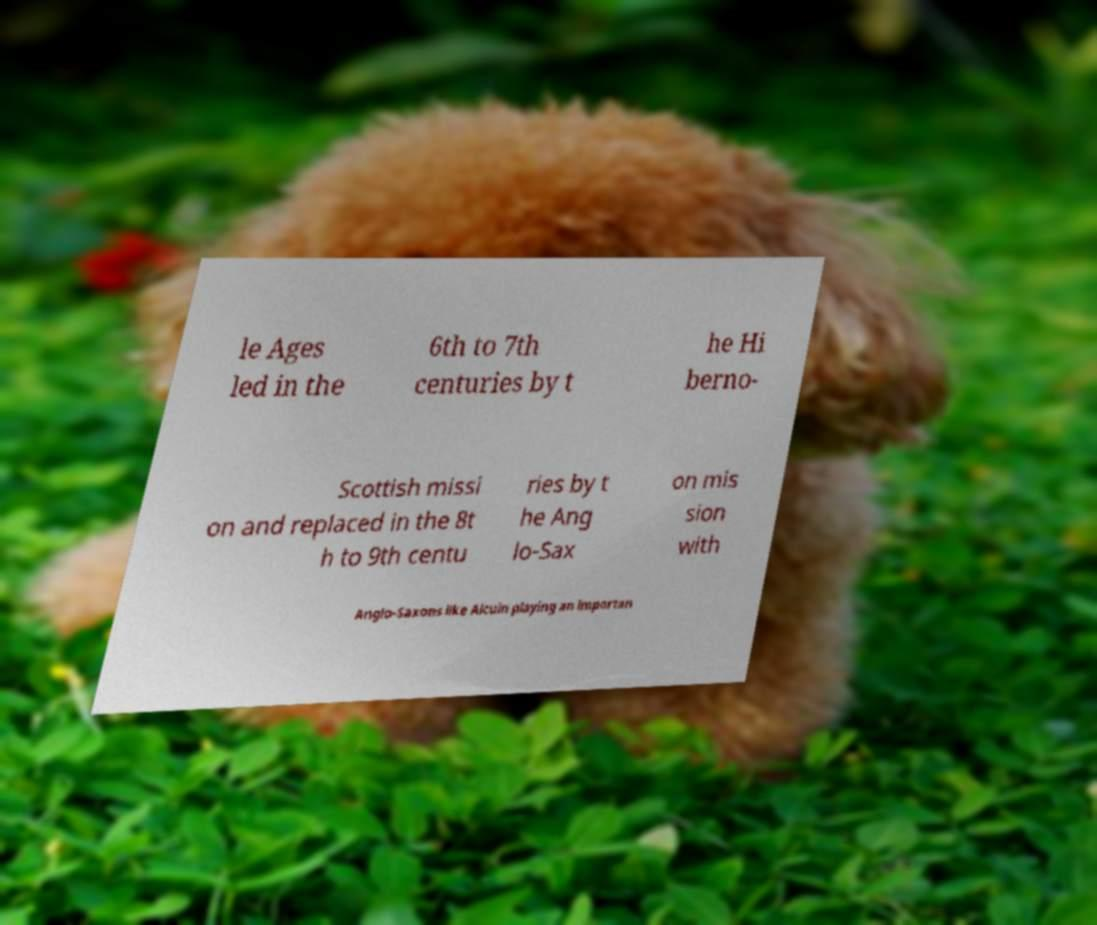What messages or text are displayed in this image? I need them in a readable, typed format. le Ages led in the 6th to 7th centuries by t he Hi berno- Scottish missi on and replaced in the 8t h to 9th centu ries by t he Ang lo-Sax on mis sion with Anglo-Saxons like Alcuin playing an importan 